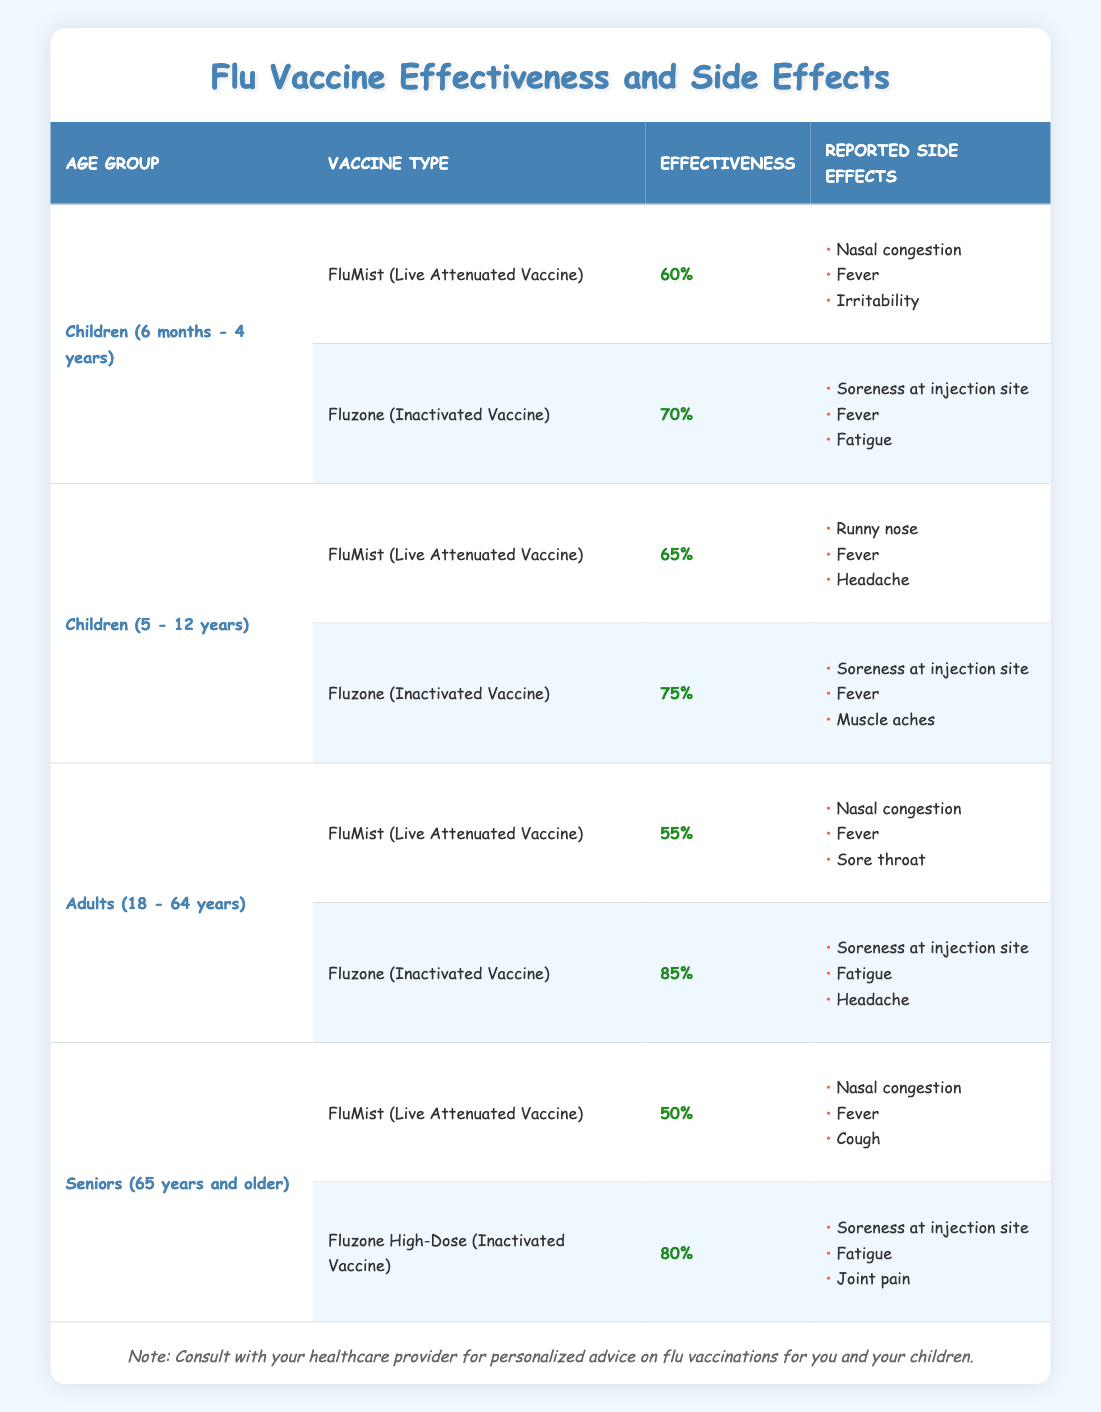What is the effectiveness of the Fluzone vaccine for children aged 5 to 12 years? The table indicates that the effectiveness of the Fluzone (Inactivated Vaccine) for children aged 5 to 12 years is 75%.
Answer: 75% Which age group has the highest effectiveness for flu vaccines? In the adults age group (18 - 64 years), the Fluzone (Inactivated Vaccine) has the highest effectiveness of 85%. Therefore, adults have the highest effectiveness among the groups listed.
Answer: Adults (18 - 64 years) True or false: The FluMist vaccine is reported to have the highest effectiveness among all age groups. When comparing the effectiveness of FluMist across all age groups, it has 60% for children (6 months - 4 years), 65% for children (5 - 12 years), 55% for adults (18 - 64 years), and 50% for seniors (65 years and older). All effectiveness percentages of FluMist are lower than that of Fluzone in the respective age groups, which means this statement is false.
Answer: False What are the reported side effects for the Fluzone High-Dose vaccine in seniors? According to the table, the reported side effects for the Fluzone High-Dose (Inactivated Vaccine) in seniors (65 years and older) include soreness at the injection site, fatigue, and joint pain.
Answer: Soreness at injection site, fatigue, joint pain If we were to compare the effectiveness of both vaccines for children aged 6 months to 4 years, what is the difference in effectiveness? The effectiveness of Fluzone (70%) compared to FluMist (60%) shows a difference of 10%. We calculate it by subtracting 60% from 70%, giving us an effectiveness difference of 10%.
Answer: 10% 